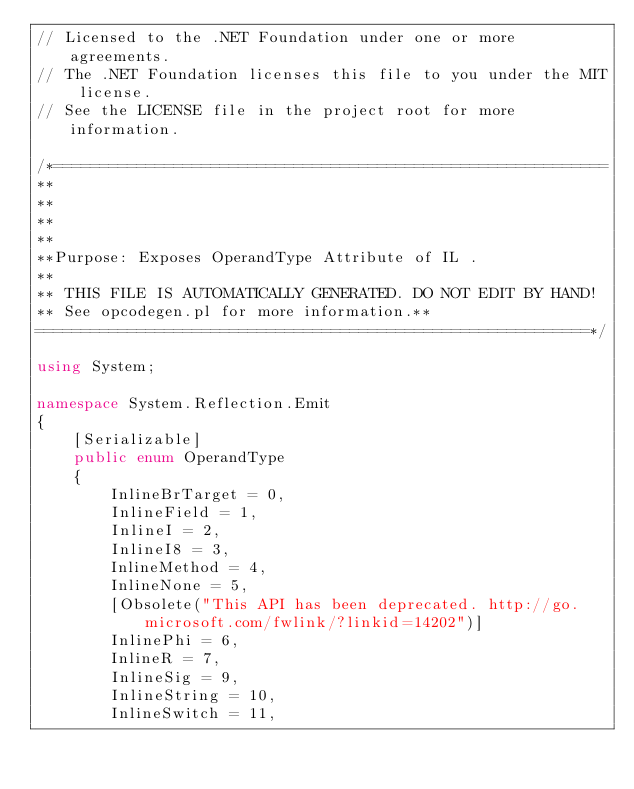<code> <loc_0><loc_0><loc_500><loc_500><_C#_>// Licensed to the .NET Foundation under one or more agreements.
// The .NET Foundation licenses this file to you under the MIT license.
// See the LICENSE file in the project root for more information.

/*============================================================
**
** 
** 
**
**Purpose: Exposes OperandType Attribute of IL .
**
** THIS FILE IS AUTOMATICALLY GENERATED. DO NOT EDIT BY HAND!
** See opcodegen.pl for more information.**
============================================================*/

using System;

namespace System.Reflection.Emit
{
    [Serializable]
    public enum OperandType
    {
        InlineBrTarget = 0,
        InlineField = 1,
        InlineI = 2,
        InlineI8 = 3,
        InlineMethod = 4,
        InlineNone = 5,
        [Obsolete("This API has been deprecated. http://go.microsoft.com/fwlink/?linkid=14202")]
        InlinePhi = 6,
        InlineR = 7,
        InlineSig = 9,
        InlineString = 10,
        InlineSwitch = 11,</code> 